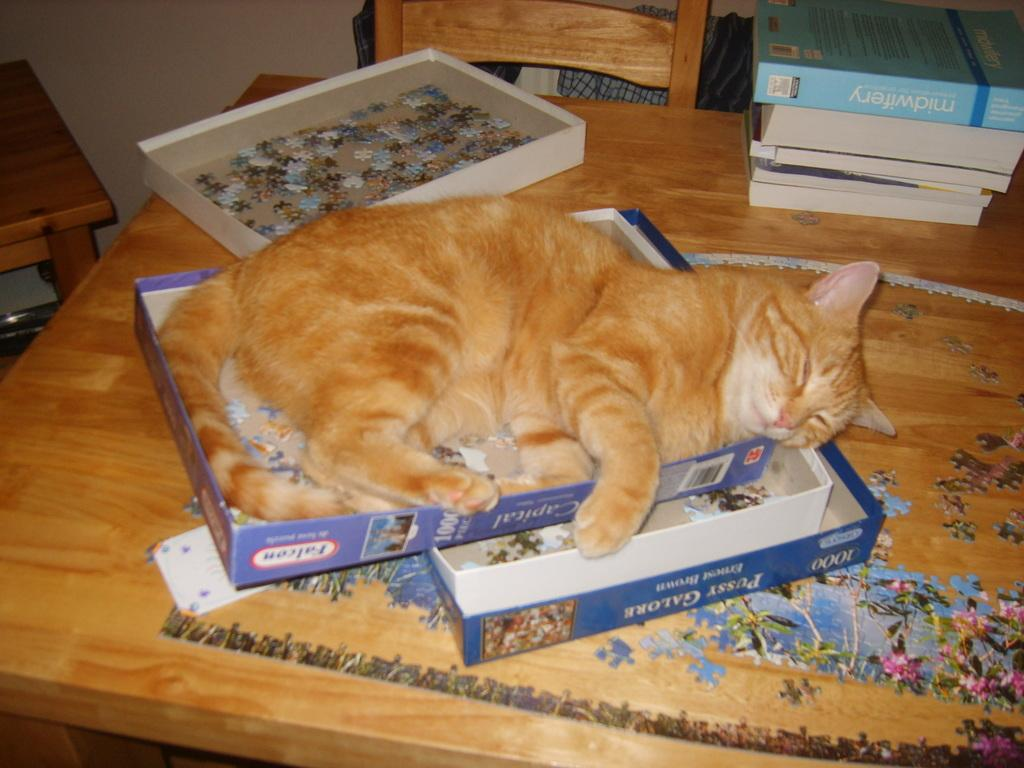What animal is present in the image? There is a cat in the image. What is the cat doing in the image? The cat is sleeping on a box. Where is the box located in the image? The box is on a table. What can be seen in the background of the image? There is a wall, a jigsaw puzzle, and a chair with books in the background of the image. What type of corn is being used for writing on the list in the image? There is no corn, writing, or list present in the image. 